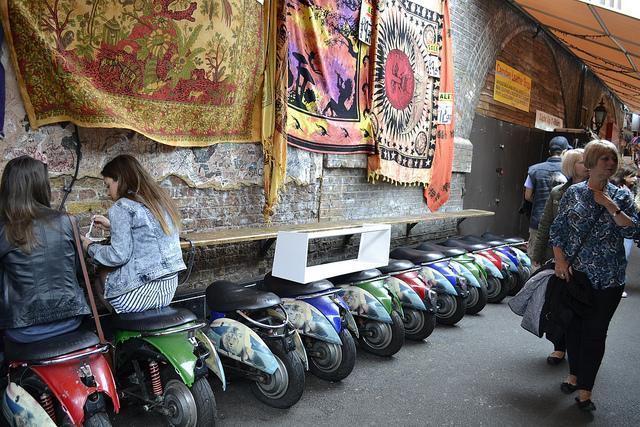How many people are sitting down?
Give a very brief answer. 2. How many people are there?
Give a very brief answer. 4. How many motorcycles can be seen?
Give a very brief answer. 7. 